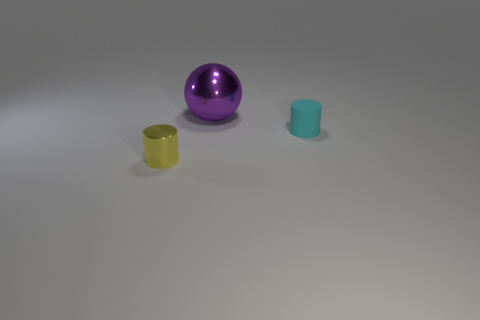Add 2 rubber cylinders. How many objects exist? 5 Subtract all balls. How many objects are left? 2 Add 2 tiny yellow metal things. How many tiny yellow metal things are left? 3 Add 3 tiny red metal cylinders. How many tiny red metal cylinders exist? 3 Subtract 0 brown spheres. How many objects are left? 3 Subtract all large objects. Subtract all cylinders. How many objects are left? 0 